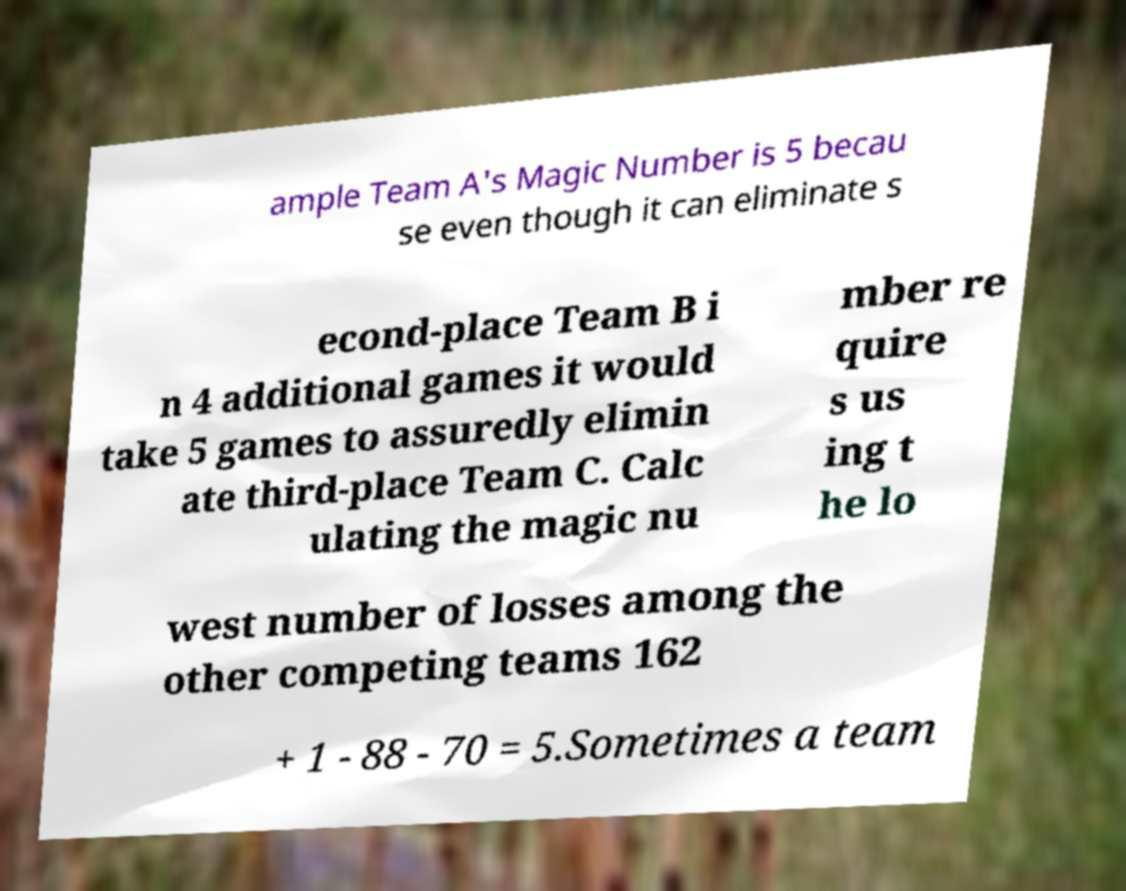Could you assist in decoding the text presented in this image and type it out clearly? ample Team A's Magic Number is 5 becau se even though it can eliminate s econd-place Team B i n 4 additional games it would take 5 games to assuredly elimin ate third-place Team C. Calc ulating the magic nu mber re quire s us ing t he lo west number of losses among the other competing teams 162 + 1 - 88 - 70 = 5.Sometimes a team 